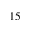<formula> <loc_0><loc_0><loc_500><loc_500>1 5</formula> 